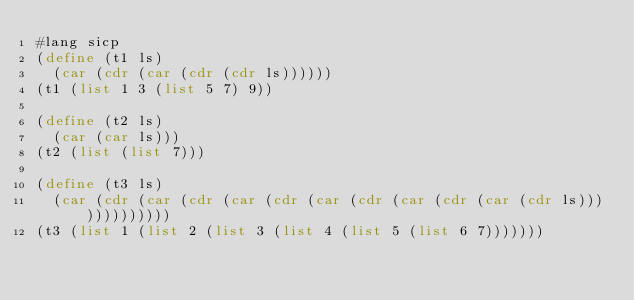<code> <loc_0><loc_0><loc_500><loc_500><_Scheme_>#lang sicp
(define (t1 ls)
  (car (cdr (car (cdr (cdr ls))))))
(t1 (list 1 3 (list 5 7) 9))

(define (t2 ls)
  (car (car ls)))
(t2 (list (list 7)))

(define (t3 ls)
  (car (cdr (car (cdr (car (cdr (car (cdr (car (cdr (car (cdr ls)))))))))))))
(t3 (list 1 (list 2 (list 3 (list 4 (list 5 (list 6 7)))))))</code> 